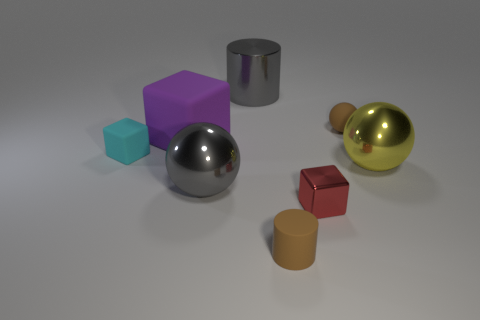Add 1 small cyan blocks. How many objects exist? 9 Subtract all cubes. How many objects are left? 5 Add 7 tiny matte balls. How many tiny matte balls exist? 8 Subtract 0 yellow cubes. How many objects are left? 8 Subtract all small brown matte things. Subtract all yellow metal things. How many objects are left? 5 Add 5 small red shiny blocks. How many small red shiny blocks are left? 6 